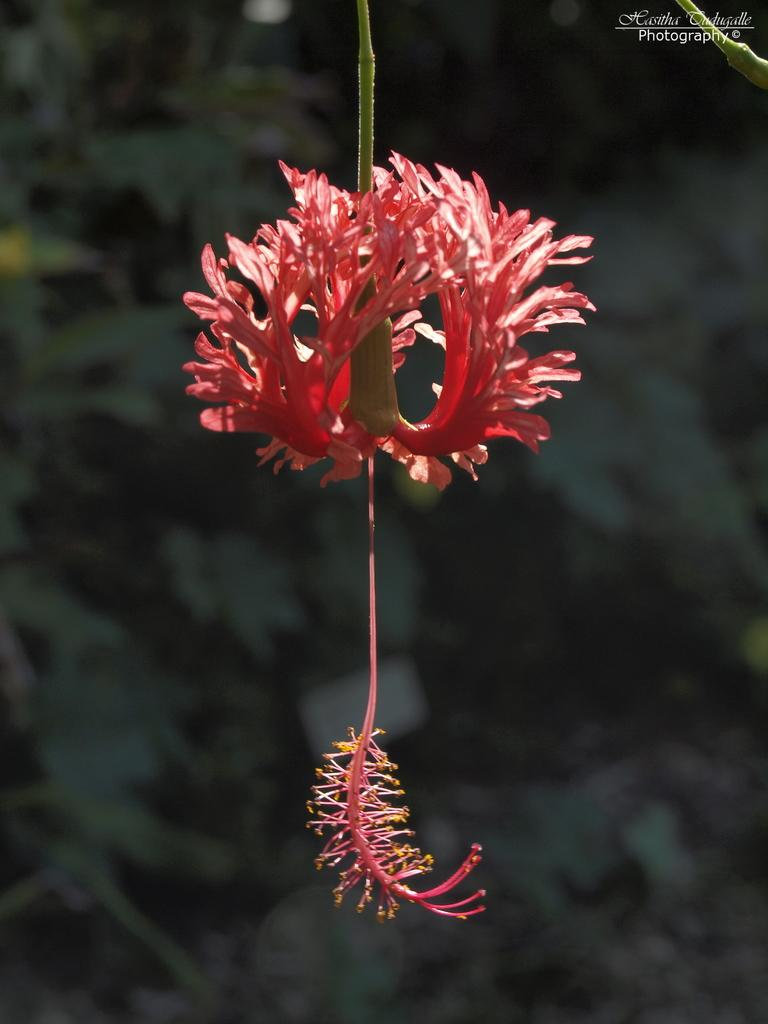What is the main subject in the front of the image? There is a flower in the front of the image. What can be seen in the background of the image? There are leaves in the background of the image. How would you describe the appearance of the background? The background appears blurry. How many times do the characters kiss in the image? There are no characters or kissing depicted in the image; it features a flower and leaves. What type of rock is visible in the image? There is no rock present in the image. 